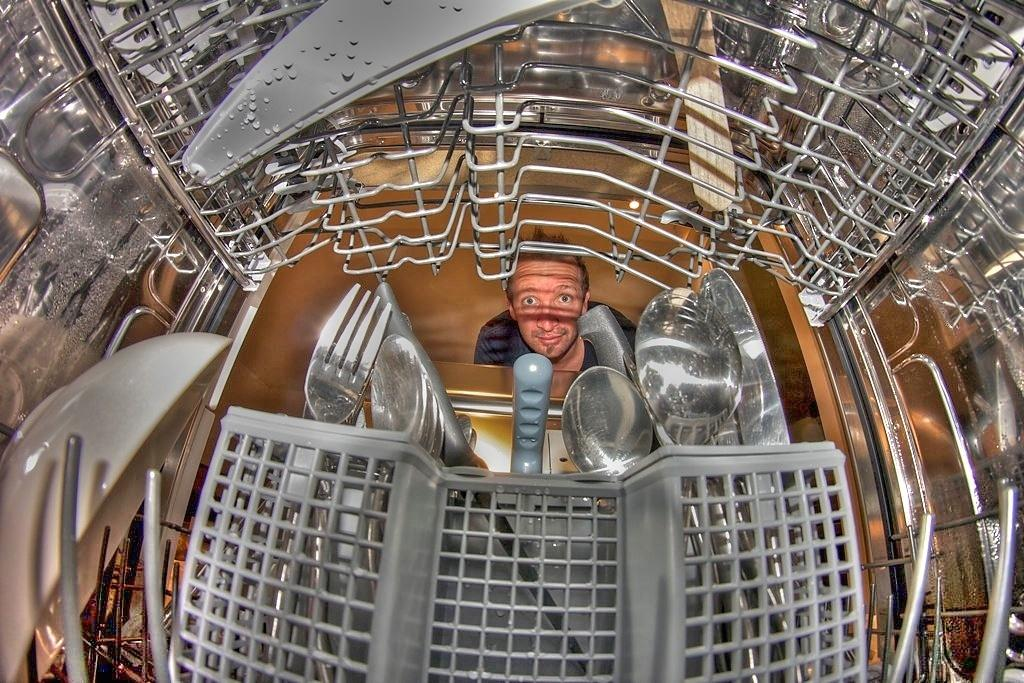What is the main subject of the image? The image shows an inside view of a dishwasher. What types of items can be seen in the dishwasher? There are utensils, a basket, iron objects, and water droplets in the dishwasher. Can you describe the condition of the items in the dishwasher? The items appear to be wet, as there are water droplets present. Is there anyone visible in the image? Yes, there is a person visible in the background of the image. What type of book is the person reading in the image? There is no book or reading activity visible in the image. How much is the person paying for the dishwasher in the image? There is no payment or transaction being depicted in the image. 